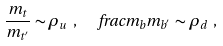Convert formula to latex. <formula><loc_0><loc_0><loc_500><loc_500>\frac { m _ { t } } { m _ { t ^ { ^ { \prime } } } } \sim \rho _ { u } \ , \ \ \ f r a c { m _ { b } } { m _ { b ^ { ^ { \prime } } } } \sim \rho _ { d } \ ,</formula> 